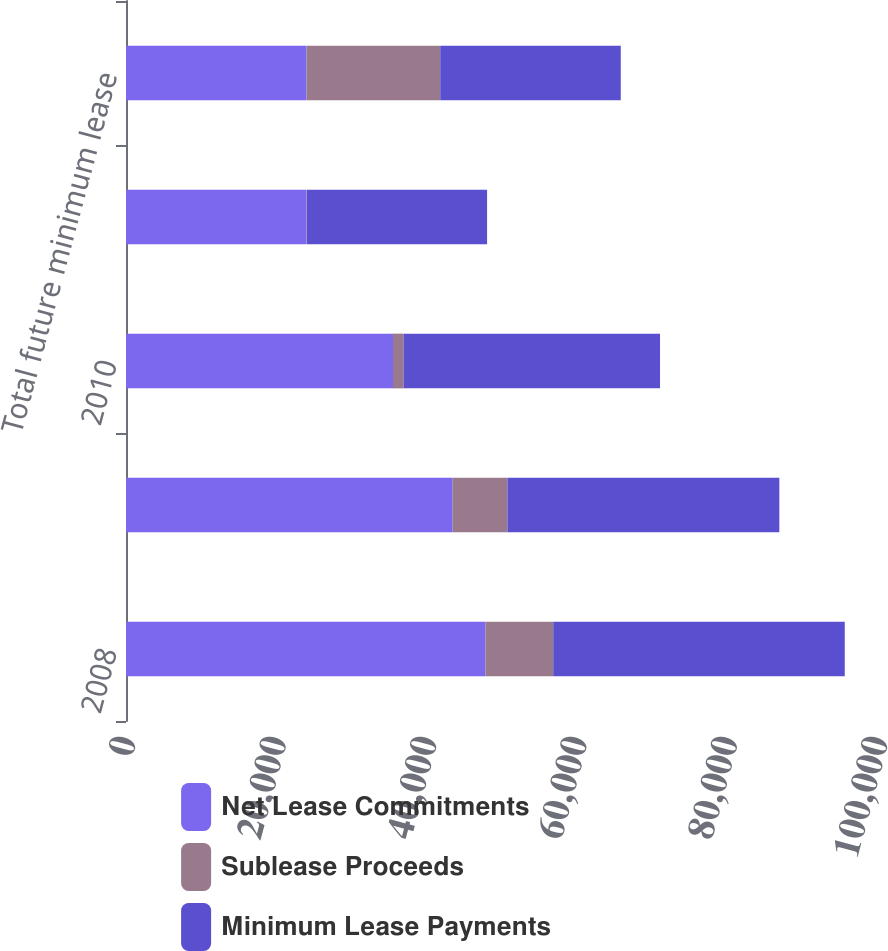Convert chart to OTSL. <chart><loc_0><loc_0><loc_500><loc_500><stacked_bar_chart><ecel><fcel>2008<fcel>2009<fcel>2010<fcel>2011<fcel>Total future minimum lease<nl><fcel>Net Lease Commitments<fcel>47790<fcel>43440<fcel>35507<fcel>24008<fcel>24008<nl><fcel>Sublease Proceeds<fcel>9023<fcel>7287<fcel>1412<fcel>56<fcel>17778<nl><fcel>Minimum Lease Payments<fcel>38767<fcel>36153<fcel>34095<fcel>23952<fcel>24008<nl></chart> 